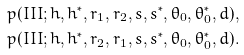<formula> <loc_0><loc_0><loc_500><loc_500>p ( I I I ; h , h ^ { * } , r _ { 1 } , r _ { 2 } , s , s ^ { * } , \theta _ { 0 } , \theta _ { 0 } ^ { * } , d ) , \\ p ( I I I ; h , h ^ { * } , r _ { 2 } , r _ { 1 } , s , s ^ { * } , \theta _ { 0 } , \theta _ { 0 } ^ { * } , d ) .</formula> 